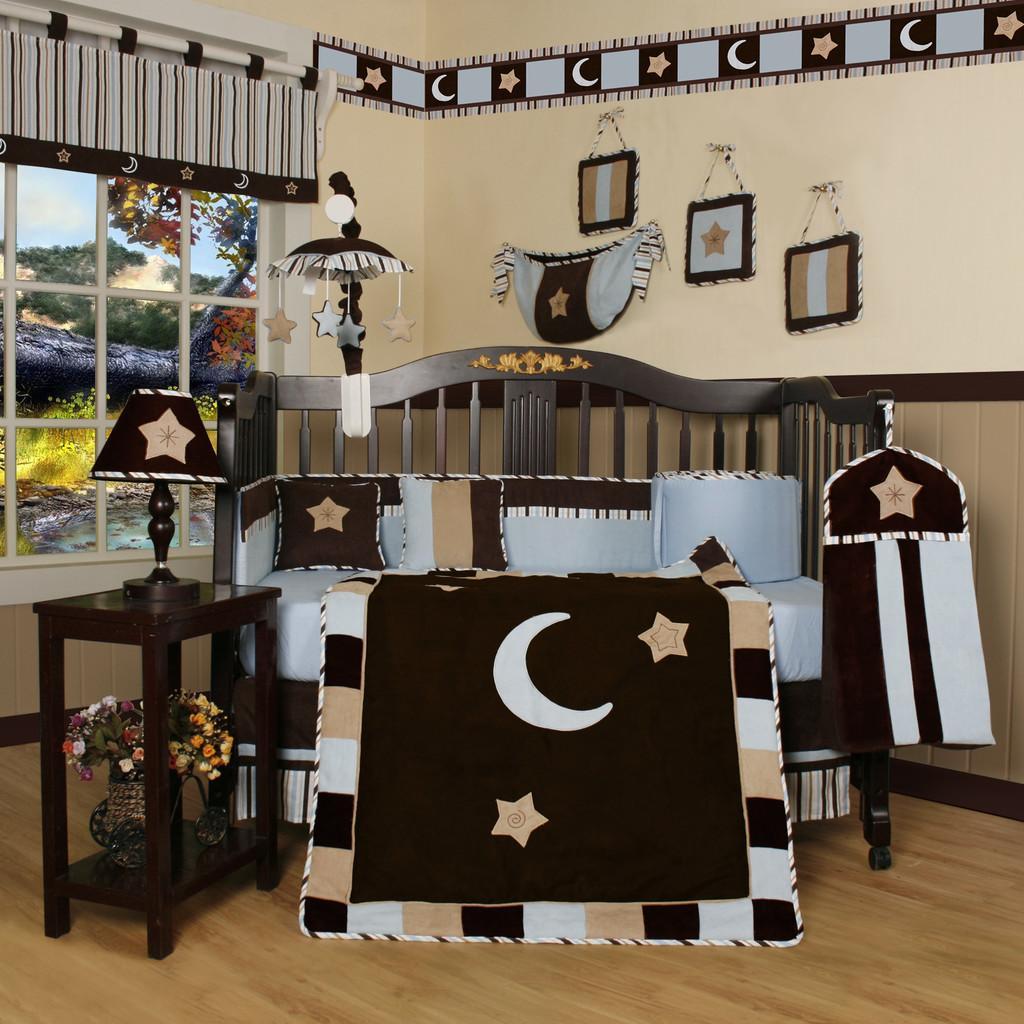In one or two sentences, can you explain what this image depicts? In this picture we can see a couch and a table in the front, there are pillows on the couch, there is a light on the table, at the bottom there is a flower vase, in the background there is a wall, we can see some bags on the wall, on the left side there is a window, from the window we can see plants and the sky. 